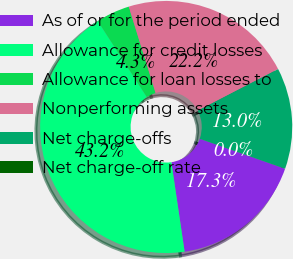Convert chart. <chart><loc_0><loc_0><loc_500><loc_500><pie_chart><fcel>As of or for the period ended<fcel>Allowance for credit losses<fcel>Allowance for loan losses to<fcel>Nonperforming assets<fcel>Net charge-offs<fcel>Net charge-off rate<nl><fcel>17.29%<fcel>43.22%<fcel>4.32%<fcel>22.2%<fcel>12.97%<fcel>0.0%<nl></chart> 